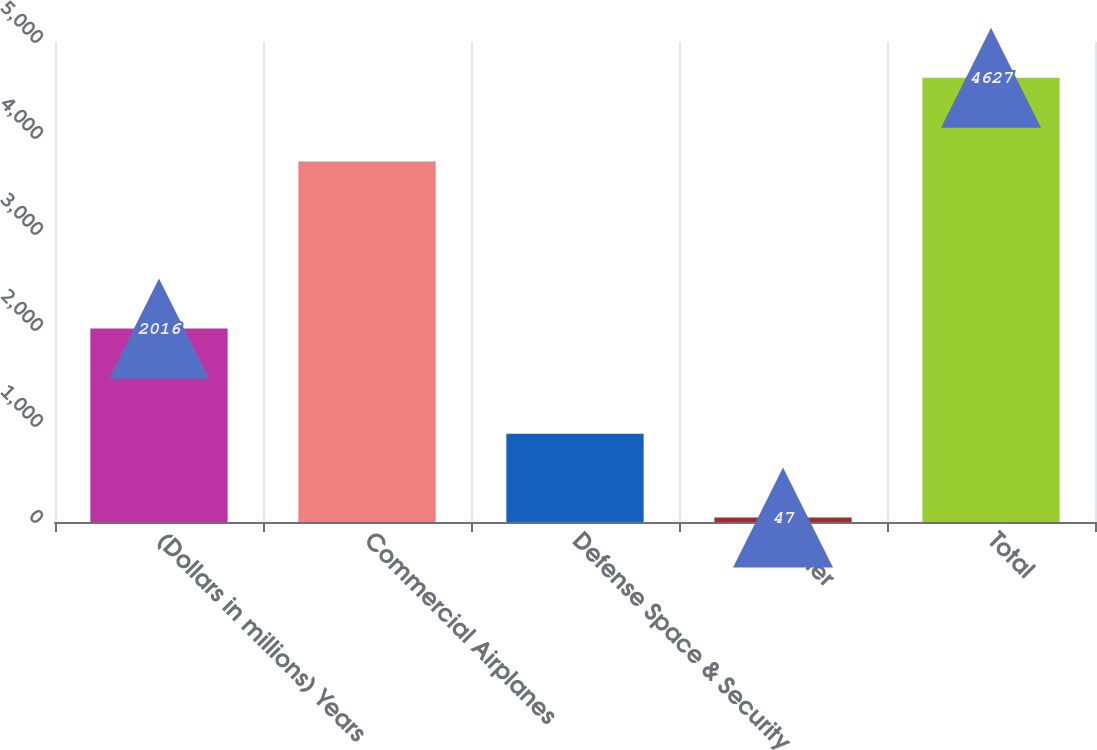<chart> <loc_0><loc_0><loc_500><loc_500><bar_chart><fcel>(Dollars in millions) Years<fcel>Commercial Airplanes<fcel>Defense Space & Security<fcel>Other<fcel>Total<nl><fcel>2016<fcel>3755<fcel>919<fcel>47<fcel>4627<nl></chart> 